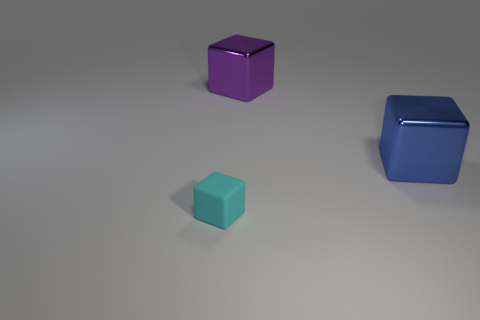How does the lighting in the scene affect the appearance of the objects? The lighting in the scene casts soft shadows and gives the objects a slight gloss, suggesting a diffused light source, which softens the appearance of the objects and provides a calm atmosphere. 